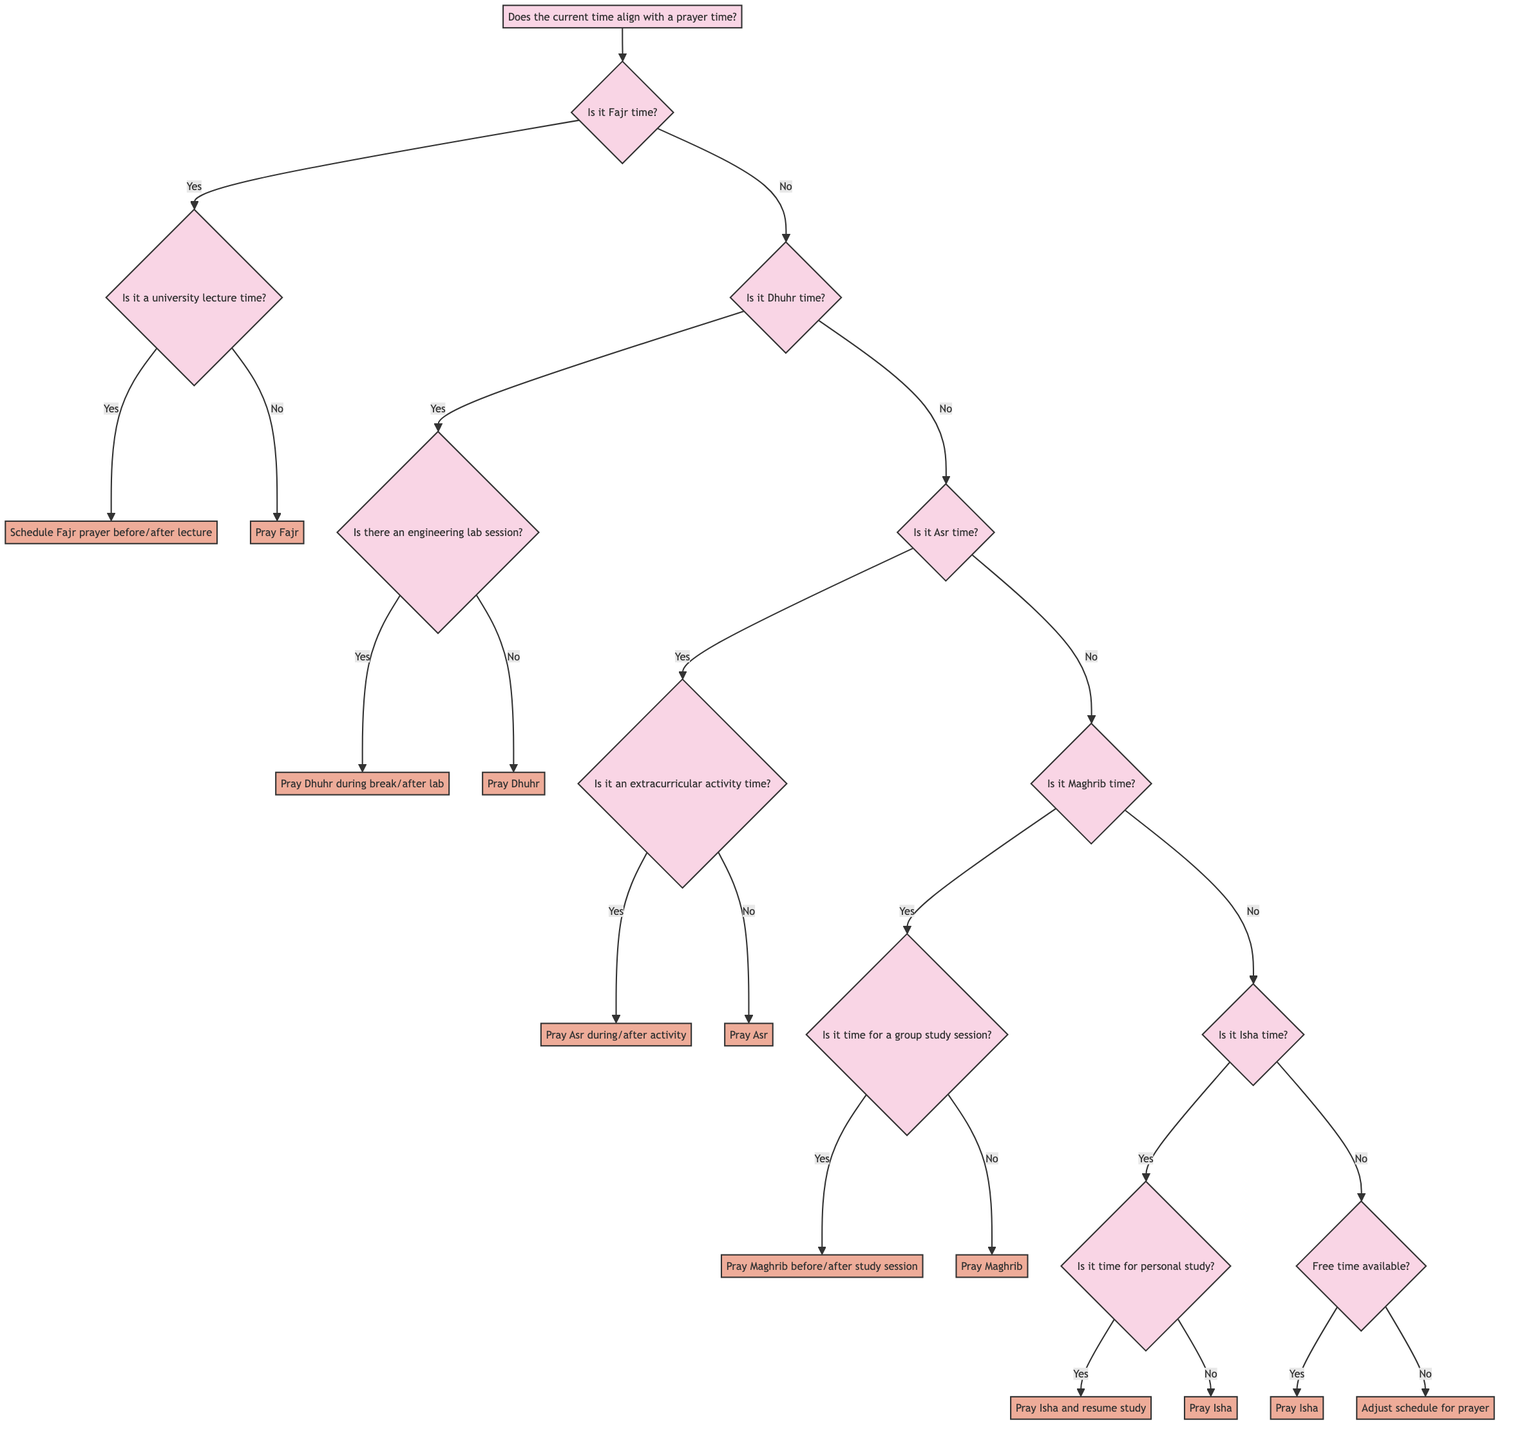What is the starting node of the diagram? The starting node of the diagram is "Does the current time align with a prayer time?" which serves as the initial question to decide the following steps based on the current time in relation to prayer times.
Answer: Does the current time align with a prayer time? How many main prayer times are included in the decision tree? The decision tree includes four main prayer times: Fajr, Dhuhr, Asr, Maghrib, and Isha, which are central in guiding the decision-making process for scheduling prayers throughout the day.
Answer: Five What action is suggested if it is Fajr time and not during a university lecture? If it is Fajr time and not during a university lecture, the diagram suggests the action to "Pray Fajr," indicating that the individual can take the time to pray without any scheduling conflicts.
Answer: Pray Fajr What question follows if it is Dhuhr time? If it is Dhuhr time, the next question is "Is there an engineering lab session?" which helps determine whether to find a break or immediately pray based on the lab schedule.
Answer: Is there an engineering lab session? If it is Isha time and there is no free time available, what should be done? If it is Isha time and there is no free time available, the diagram indicates that one should "Adjust schedule to create time for prayer," showing the necessity of prioritizing prayer even in a busy schedule.
Answer: Adjust schedule to create time for prayer Is there an option to pray Dhuhr during a break? Yes, if it is Dhuhr time and there is an engineering lab session, it suggests to "Find a break within lab session or pray immediately after the lab," indicating flexibility in scheduling prayers around academic commitments.
Answer: Find a break or pray immediately after the lab What is the decision at the node questioning the availability of free time during Isha? At the node questioning the availability of free time during Isha, it presents two possible actions: if yes, "Pray Isha," and if no, "Adjust schedule for prayer," emphasizing the need to make time for the prayer.
Answer: Pray Isha or Adjust schedule for prayer 